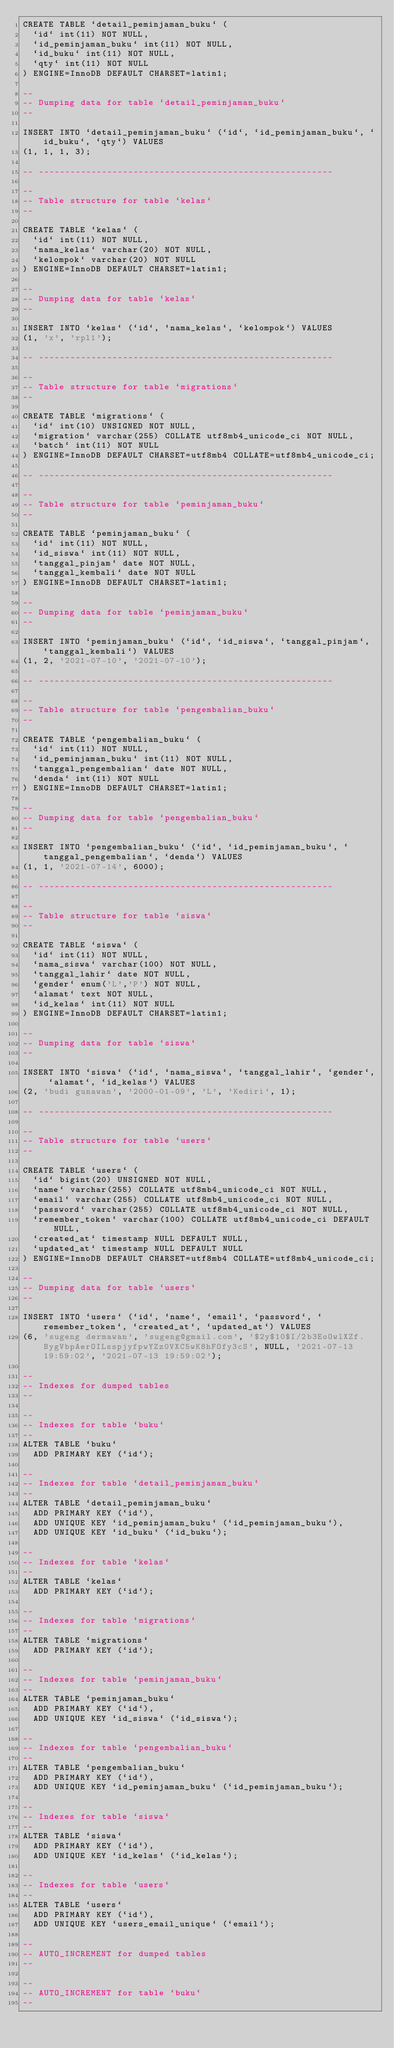<code> <loc_0><loc_0><loc_500><loc_500><_SQL_>CREATE TABLE `detail_peminjaman_buku` (
  `id` int(11) NOT NULL,
  `id_peminjaman_buku` int(11) NOT NULL,
  `id_buku` int(11) NOT NULL,
  `qty` int(11) NOT NULL
) ENGINE=InnoDB DEFAULT CHARSET=latin1;

--
-- Dumping data for table `detail_peminjaman_buku`
--

INSERT INTO `detail_peminjaman_buku` (`id`, `id_peminjaman_buku`, `id_buku`, `qty`) VALUES
(1, 1, 1, 3);

-- --------------------------------------------------------

--
-- Table structure for table `kelas`
--

CREATE TABLE `kelas` (
  `id` int(11) NOT NULL,
  `nama_kelas` varchar(20) NOT NULL,
  `kelompok` varchar(20) NOT NULL
) ENGINE=InnoDB DEFAULT CHARSET=latin1;

--
-- Dumping data for table `kelas`
--

INSERT INTO `kelas` (`id`, `nama_kelas`, `kelompok`) VALUES
(1, 'x', 'rpl1');

-- --------------------------------------------------------

--
-- Table structure for table `migrations`
--

CREATE TABLE `migrations` (
  `id` int(10) UNSIGNED NOT NULL,
  `migration` varchar(255) COLLATE utf8mb4_unicode_ci NOT NULL,
  `batch` int(11) NOT NULL
) ENGINE=InnoDB DEFAULT CHARSET=utf8mb4 COLLATE=utf8mb4_unicode_ci;

-- --------------------------------------------------------

--
-- Table structure for table `peminjaman_buku`
--

CREATE TABLE `peminjaman_buku` (
  `id` int(11) NOT NULL,
  `id_siswa` int(11) NOT NULL,
  `tanggal_pinjam` date NOT NULL,
  `tanggal_kembali` date NOT NULL
) ENGINE=InnoDB DEFAULT CHARSET=latin1;

--
-- Dumping data for table `peminjaman_buku`
--

INSERT INTO `peminjaman_buku` (`id`, `id_siswa`, `tanggal_pinjam`, `tanggal_kembali`) VALUES
(1, 2, '2021-07-10', '2021-07-10');

-- --------------------------------------------------------

--
-- Table structure for table `pengembalian_buku`
--

CREATE TABLE `pengembalian_buku` (
  `id` int(11) NOT NULL,
  `id_peminjaman_buku` int(11) NOT NULL,
  `tanggal_pengembalian` date NOT NULL,
  `denda` int(11) NOT NULL
) ENGINE=InnoDB DEFAULT CHARSET=latin1;

--
-- Dumping data for table `pengembalian_buku`
--

INSERT INTO `pengembalian_buku` (`id`, `id_peminjaman_buku`, `tanggal_pengembalian`, `denda`) VALUES
(1, 1, '2021-07-14', 6000);

-- --------------------------------------------------------

--
-- Table structure for table `siswa`
--

CREATE TABLE `siswa` (
  `id` int(11) NOT NULL,
  `nama_siswa` varchar(100) NOT NULL,
  `tanggal_lahir` date NOT NULL,
  `gender` enum('L','P') NOT NULL,
  `alamat` text NOT NULL,
  `id_kelas` int(11) NOT NULL
) ENGINE=InnoDB DEFAULT CHARSET=latin1;

--
-- Dumping data for table `siswa`
--

INSERT INTO `siswa` (`id`, `nama_siswa`, `tanggal_lahir`, `gender`, `alamat`, `id_kelas`) VALUES
(2, 'budi gunawan', '2000-01-09', 'L', 'Kediri', 1);

-- --------------------------------------------------------

--
-- Table structure for table `users`
--

CREATE TABLE `users` (
  `id` bigint(20) UNSIGNED NOT NULL,
  `name` varchar(255) COLLATE utf8mb4_unicode_ci NOT NULL,
  `email` varchar(255) COLLATE utf8mb4_unicode_ci NOT NULL,
  `password` varchar(255) COLLATE utf8mb4_unicode_ci NOT NULL,
  `remember_token` varchar(100) COLLATE utf8mb4_unicode_ci DEFAULT NULL,
  `created_at` timestamp NULL DEFAULT NULL,
  `updated_at` timestamp NULL DEFAULT NULL
) ENGINE=InnoDB DEFAULT CHARSET=utf8mb4 COLLATE=utf8mb4_unicode_ci;

--
-- Dumping data for table `users`
--

INSERT INTO `users` (`id`, `name`, `email`, `password`, `remember_token`, `created_at`, `updated_at`) VALUES
(6, 'sugeng dermawan', 'sugeng@gmail.com', '$2y$10$I/2b3EoOwlXZf.BygVbpAerOILsspjyfpwYZz0VXC5wK8hFOfy3cS', NULL, '2021-07-13 19:59:02', '2021-07-13 19:59:02');

--
-- Indexes for dumped tables
--

--
-- Indexes for table `buku`
--
ALTER TABLE `buku`
  ADD PRIMARY KEY (`id`);

--
-- Indexes for table `detail_peminjaman_buku`
--
ALTER TABLE `detail_peminjaman_buku`
  ADD PRIMARY KEY (`id`),
  ADD UNIQUE KEY `id_peminjaman_buku` (`id_peminjaman_buku`),
  ADD UNIQUE KEY `id_buku` (`id_buku`);

--
-- Indexes for table `kelas`
--
ALTER TABLE `kelas`
  ADD PRIMARY KEY (`id`);

--
-- Indexes for table `migrations`
--
ALTER TABLE `migrations`
  ADD PRIMARY KEY (`id`);

--
-- Indexes for table `peminjaman_buku`
--
ALTER TABLE `peminjaman_buku`
  ADD PRIMARY KEY (`id`),
  ADD UNIQUE KEY `id_siswa` (`id_siswa`);

--
-- Indexes for table `pengembalian_buku`
--
ALTER TABLE `pengembalian_buku`
  ADD PRIMARY KEY (`id`),
  ADD UNIQUE KEY `id_peminjaman_buku` (`id_peminjaman_buku`);

--
-- Indexes for table `siswa`
--
ALTER TABLE `siswa`
  ADD PRIMARY KEY (`id`),
  ADD UNIQUE KEY `id_kelas` (`id_kelas`);

--
-- Indexes for table `users`
--
ALTER TABLE `users`
  ADD PRIMARY KEY (`id`),
  ADD UNIQUE KEY `users_email_unique` (`email`);

--
-- AUTO_INCREMENT for dumped tables
--

--
-- AUTO_INCREMENT for table `buku`
--</code> 